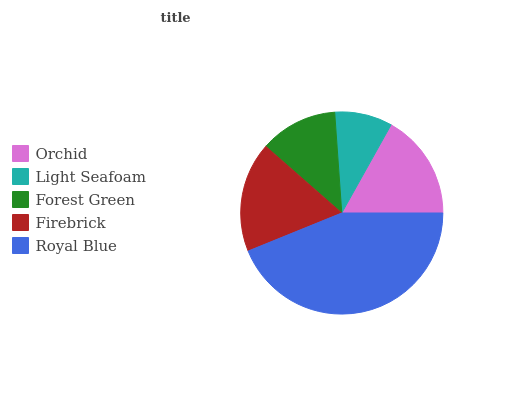Is Light Seafoam the minimum?
Answer yes or no. Yes. Is Royal Blue the maximum?
Answer yes or no. Yes. Is Forest Green the minimum?
Answer yes or no. No. Is Forest Green the maximum?
Answer yes or no. No. Is Forest Green greater than Light Seafoam?
Answer yes or no. Yes. Is Light Seafoam less than Forest Green?
Answer yes or no. Yes. Is Light Seafoam greater than Forest Green?
Answer yes or no. No. Is Forest Green less than Light Seafoam?
Answer yes or no. No. Is Orchid the high median?
Answer yes or no. Yes. Is Orchid the low median?
Answer yes or no. Yes. Is Light Seafoam the high median?
Answer yes or no. No. Is Royal Blue the low median?
Answer yes or no. No. 